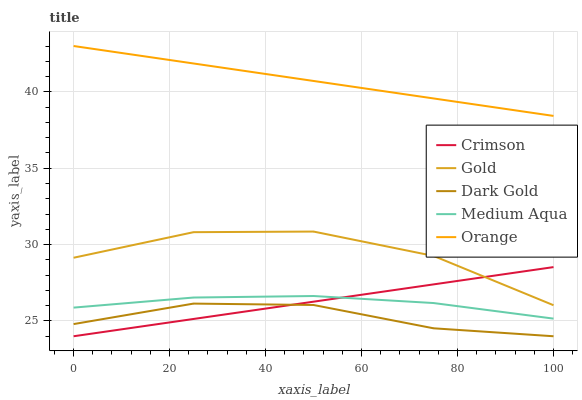Does Dark Gold have the minimum area under the curve?
Answer yes or no. Yes. Does Orange have the maximum area under the curve?
Answer yes or no. Yes. Does Medium Aqua have the minimum area under the curve?
Answer yes or no. No. Does Medium Aqua have the maximum area under the curve?
Answer yes or no. No. Is Crimson the smoothest?
Answer yes or no. Yes. Is Gold the roughest?
Answer yes or no. Yes. Is Medium Aqua the smoothest?
Answer yes or no. No. Is Medium Aqua the roughest?
Answer yes or no. No. Does Crimson have the lowest value?
Answer yes or no. Yes. Does Medium Aqua have the lowest value?
Answer yes or no. No. Does Orange have the highest value?
Answer yes or no. Yes. Does Medium Aqua have the highest value?
Answer yes or no. No. Is Dark Gold less than Medium Aqua?
Answer yes or no. Yes. Is Orange greater than Gold?
Answer yes or no. Yes. Does Crimson intersect Medium Aqua?
Answer yes or no. Yes. Is Crimson less than Medium Aqua?
Answer yes or no. No. Is Crimson greater than Medium Aqua?
Answer yes or no. No. Does Dark Gold intersect Medium Aqua?
Answer yes or no. No. 